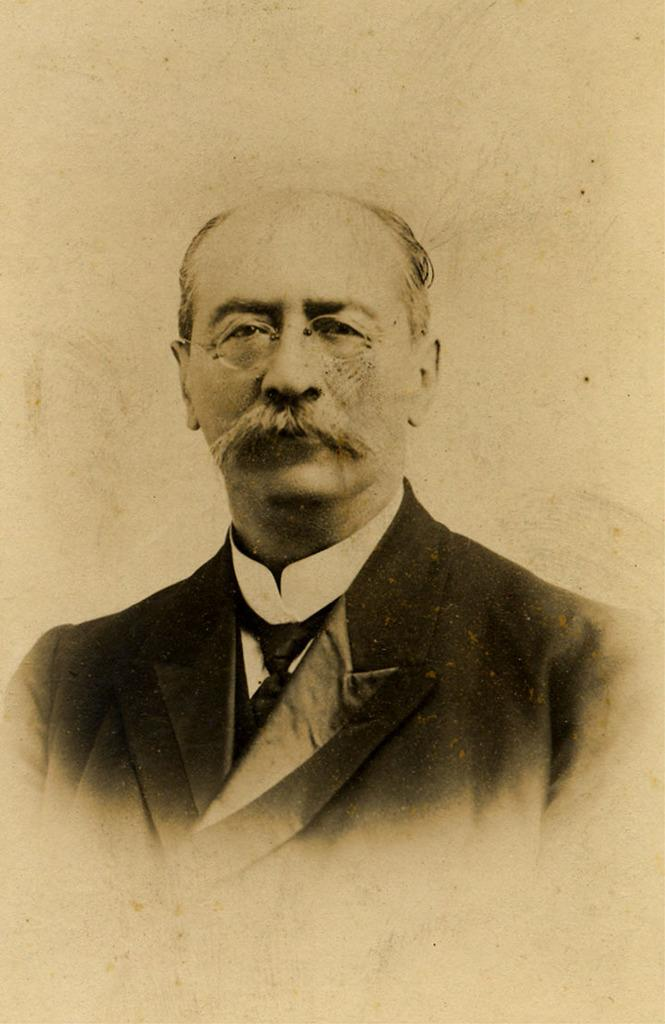Who or what is present in the image? There is a person in the image. What type of clothing is the person wearing? The person is wearing a blazer, a shirt, and a tie. What color is the background of the image? The background of the image is white. What type of wax or polish is being applied to the person's clothing in the image? There is no indication in the image that wax or polish is being applied to the person's clothing. 